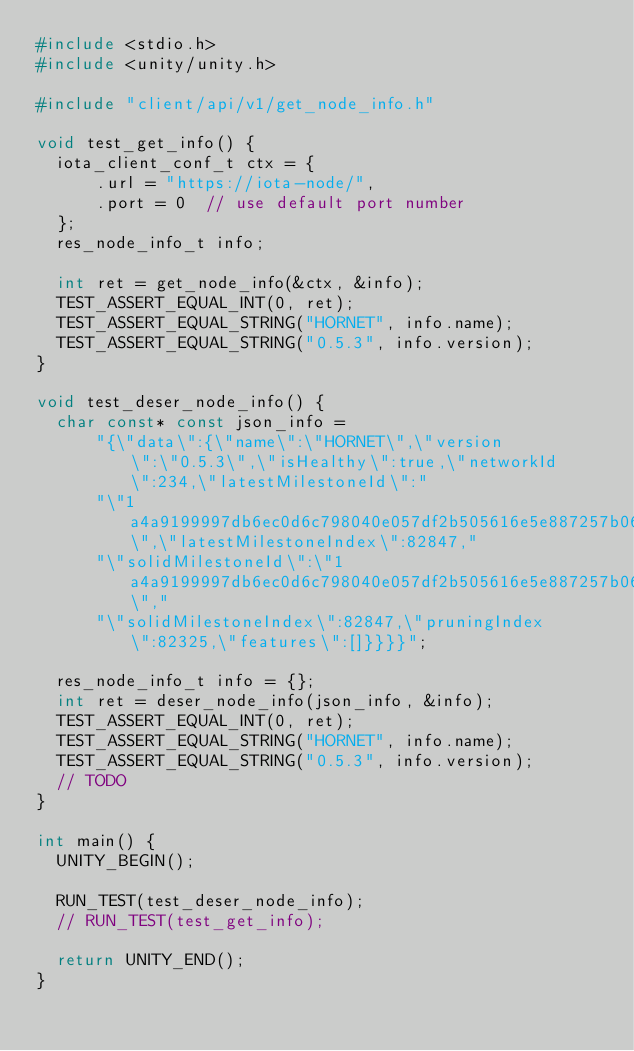<code> <loc_0><loc_0><loc_500><loc_500><_C_>#include <stdio.h>
#include <unity/unity.h>

#include "client/api/v1/get_node_info.h"

void test_get_info() {
  iota_client_conf_t ctx = {
      .url = "https://iota-node/",
      .port = 0  // use default port number
  };
  res_node_info_t info;

  int ret = get_node_info(&ctx, &info);
  TEST_ASSERT_EQUAL_INT(0, ret);
  TEST_ASSERT_EQUAL_STRING("HORNET", info.name);
  TEST_ASSERT_EQUAL_STRING("0.5.3", info.version);
}

void test_deser_node_info() {
  char const* const json_info =
      "{\"data\":{\"name\":\"HORNET\",\"version\":\"0.5.3\",\"isHealthy\":true,\"networkId\":234,\"latestMilestoneId\":"
      "\"1a4a9199997db6ec0d6c798040e057df2b505616e5e887257b0600eee49f6345\",\"latestMilestoneIndex\":82847,"
      "\"solidMilestoneId\":\"1a4a9199997db6ec0d6c798040e057df2b505616e5e887257b0600eee49f6345\","
      "\"solidMilestoneIndex\":82847,\"pruningIndex\":82325,\"features\":[]}}}}";

  res_node_info_t info = {};
  int ret = deser_node_info(json_info, &info);
  TEST_ASSERT_EQUAL_INT(0, ret);
  TEST_ASSERT_EQUAL_STRING("HORNET", info.name);
  TEST_ASSERT_EQUAL_STRING("0.5.3", info.version);
  // TODO
}

int main() {
  UNITY_BEGIN();

  RUN_TEST(test_deser_node_info);
  // RUN_TEST(test_get_info);

  return UNITY_END();
}</code> 